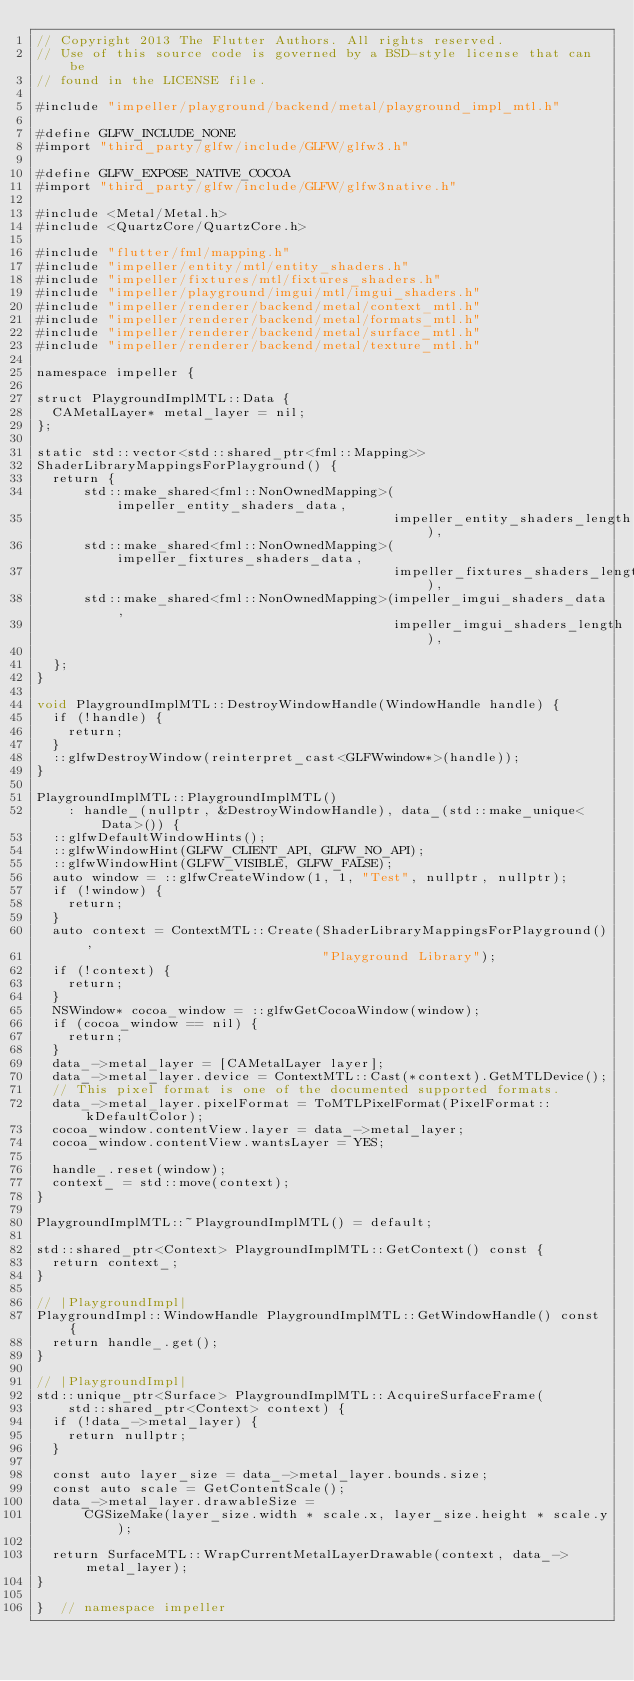<code> <loc_0><loc_0><loc_500><loc_500><_ObjectiveC_>// Copyright 2013 The Flutter Authors. All rights reserved.
// Use of this source code is governed by a BSD-style license that can be
// found in the LICENSE file.

#include "impeller/playground/backend/metal/playground_impl_mtl.h"

#define GLFW_INCLUDE_NONE
#import "third_party/glfw/include/GLFW/glfw3.h"

#define GLFW_EXPOSE_NATIVE_COCOA
#import "third_party/glfw/include/GLFW/glfw3native.h"

#include <Metal/Metal.h>
#include <QuartzCore/QuartzCore.h>

#include "flutter/fml/mapping.h"
#include "impeller/entity/mtl/entity_shaders.h"
#include "impeller/fixtures/mtl/fixtures_shaders.h"
#include "impeller/playground/imgui/mtl/imgui_shaders.h"
#include "impeller/renderer/backend/metal/context_mtl.h"
#include "impeller/renderer/backend/metal/formats_mtl.h"
#include "impeller/renderer/backend/metal/surface_mtl.h"
#include "impeller/renderer/backend/metal/texture_mtl.h"

namespace impeller {

struct PlaygroundImplMTL::Data {
  CAMetalLayer* metal_layer = nil;
};

static std::vector<std::shared_ptr<fml::Mapping>>
ShaderLibraryMappingsForPlayground() {
  return {
      std::make_shared<fml::NonOwnedMapping>(impeller_entity_shaders_data,
                                             impeller_entity_shaders_length),
      std::make_shared<fml::NonOwnedMapping>(impeller_fixtures_shaders_data,
                                             impeller_fixtures_shaders_length),
      std::make_shared<fml::NonOwnedMapping>(impeller_imgui_shaders_data,
                                             impeller_imgui_shaders_length),

  };
}

void PlaygroundImplMTL::DestroyWindowHandle(WindowHandle handle) {
  if (!handle) {
    return;
  }
  ::glfwDestroyWindow(reinterpret_cast<GLFWwindow*>(handle));
}

PlaygroundImplMTL::PlaygroundImplMTL()
    : handle_(nullptr, &DestroyWindowHandle), data_(std::make_unique<Data>()) {
  ::glfwDefaultWindowHints();
  ::glfwWindowHint(GLFW_CLIENT_API, GLFW_NO_API);
  ::glfwWindowHint(GLFW_VISIBLE, GLFW_FALSE);
  auto window = ::glfwCreateWindow(1, 1, "Test", nullptr, nullptr);
  if (!window) {
    return;
  }
  auto context = ContextMTL::Create(ShaderLibraryMappingsForPlayground(),
                                    "Playground Library");
  if (!context) {
    return;
  }
  NSWindow* cocoa_window = ::glfwGetCocoaWindow(window);
  if (cocoa_window == nil) {
    return;
  }
  data_->metal_layer = [CAMetalLayer layer];
  data_->metal_layer.device = ContextMTL::Cast(*context).GetMTLDevice();
  // This pixel format is one of the documented supported formats.
  data_->metal_layer.pixelFormat = ToMTLPixelFormat(PixelFormat::kDefaultColor);
  cocoa_window.contentView.layer = data_->metal_layer;
  cocoa_window.contentView.wantsLayer = YES;

  handle_.reset(window);
  context_ = std::move(context);
}

PlaygroundImplMTL::~PlaygroundImplMTL() = default;

std::shared_ptr<Context> PlaygroundImplMTL::GetContext() const {
  return context_;
}

// |PlaygroundImpl|
PlaygroundImpl::WindowHandle PlaygroundImplMTL::GetWindowHandle() const {
  return handle_.get();
}

// |PlaygroundImpl|
std::unique_ptr<Surface> PlaygroundImplMTL::AcquireSurfaceFrame(
    std::shared_ptr<Context> context) {
  if (!data_->metal_layer) {
    return nullptr;
  }

  const auto layer_size = data_->metal_layer.bounds.size;
  const auto scale = GetContentScale();
  data_->metal_layer.drawableSize =
      CGSizeMake(layer_size.width * scale.x, layer_size.height * scale.y);

  return SurfaceMTL::WrapCurrentMetalLayerDrawable(context, data_->metal_layer);
}

}  // namespace impeller
</code> 